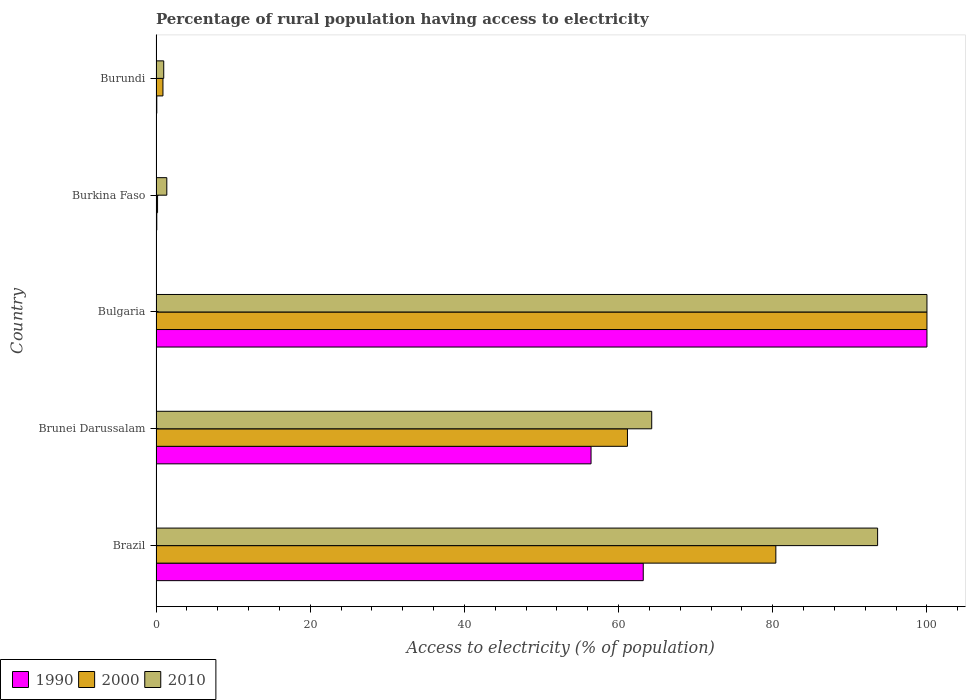How many different coloured bars are there?
Offer a very short reply. 3. How many groups of bars are there?
Give a very brief answer. 5. Are the number of bars per tick equal to the number of legend labels?
Ensure brevity in your answer.  Yes. Are the number of bars on each tick of the Y-axis equal?
Provide a succinct answer. Yes. How many bars are there on the 5th tick from the bottom?
Ensure brevity in your answer.  3. What is the label of the 2nd group of bars from the top?
Keep it short and to the point. Burkina Faso. In how many cases, is the number of bars for a given country not equal to the number of legend labels?
Ensure brevity in your answer.  0. What is the percentage of rural population having access to electricity in 2000 in Brazil?
Your response must be concise. 80.4. In which country was the percentage of rural population having access to electricity in 2000 maximum?
Your answer should be compact. Bulgaria. In which country was the percentage of rural population having access to electricity in 2010 minimum?
Provide a succinct answer. Burundi. What is the total percentage of rural population having access to electricity in 2010 in the graph?
Provide a succinct answer. 260.3. What is the difference between the percentage of rural population having access to electricity in 2000 in Brunei Darussalam and that in Burkina Faso?
Your answer should be very brief. 60.95. What is the difference between the percentage of rural population having access to electricity in 1990 in Brunei Darussalam and the percentage of rural population having access to electricity in 2000 in Brazil?
Make the answer very short. -23.97. What is the average percentage of rural population having access to electricity in 2000 per country?
Keep it short and to the point. 48.53. What is the difference between the percentage of rural population having access to electricity in 1990 and percentage of rural population having access to electricity in 2010 in Burundi?
Make the answer very short. -0.9. What is the ratio of the percentage of rural population having access to electricity in 2010 in Brunei Darussalam to that in Bulgaria?
Provide a short and direct response. 0.64. Is the percentage of rural population having access to electricity in 2010 in Brazil less than that in Burundi?
Make the answer very short. No. Is the difference between the percentage of rural population having access to electricity in 1990 in Brazil and Burkina Faso greater than the difference between the percentage of rural population having access to electricity in 2010 in Brazil and Burkina Faso?
Offer a terse response. No. What is the difference between the highest and the second highest percentage of rural population having access to electricity in 2010?
Your answer should be very brief. 6.4. What is the difference between the highest and the lowest percentage of rural population having access to electricity in 2010?
Your answer should be very brief. 99. In how many countries, is the percentage of rural population having access to electricity in 2010 greater than the average percentage of rural population having access to electricity in 2010 taken over all countries?
Your response must be concise. 3. What does the 2nd bar from the top in Brunei Darussalam represents?
Your answer should be very brief. 2000. How many countries are there in the graph?
Offer a very short reply. 5. Are the values on the major ticks of X-axis written in scientific E-notation?
Make the answer very short. No. What is the title of the graph?
Provide a succinct answer. Percentage of rural population having access to electricity. Does "2004" appear as one of the legend labels in the graph?
Your answer should be very brief. No. What is the label or title of the X-axis?
Your response must be concise. Access to electricity (% of population). What is the Access to electricity (% of population) in 1990 in Brazil?
Keep it short and to the point. 63.2. What is the Access to electricity (% of population) of 2000 in Brazil?
Keep it short and to the point. 80.4. What is the Access to electricity (% of population) of 2010 in Brazil?
Give a very brief answer. 93.6. What is the Access to electricity (% of population) in 1990 in Brunei Darussalam?
Your response must be concise. 56.43. What is the Access to electricity (% of population) in 2000 in Brunei Darussalam?
Offer a very short reply. 61.15. What is the Access to electricity (% of population) of 2010 in Brunei Darussalam?
Ensure brevity in your answer.  64.3. What is the Access to electricity (% of population) of 1990 in Bulgaria?
Your answer should be compact. 100. What is the Access to electricity (% of population) in 2000 in Bulgaria?
Your answer should be very brief. 100. What is the Access to electricity (% of population) in 2010 in Bulgaria?
Offer a terse response. 100. What is the Access to electricity (% of population) of 2010 in Burkina Faso?
Provide a short and direct response. 1.4. What is the Access to electricity (% of population) in 1990 in Burundi?
Provide a short and direct response. 0.1. Across all countries, what is the minimum Access to electricity (% of population) in 1990?
Provide a short and direct response. 0.1. Across all countries, what is the minimum Access to electricity (% of population) in 2000?
Provide a short and direct response. 0.2. Across all countries, what is the minimum Access to electricity (% of population) in 2010?
Provide a succinct answer. 1. What is the total Access to electricity (% of population) of 1990 in the graph?
Your answer should be very brief. 219.83. What is the total Access to electricity (% of population) in 2000 in the graph?
Make the answer very short. 242.65. What is the total Access to electricity (% of population) of 2010 in the graph?
Offer a terse response. 260.3. What is the difference between the Access to electricity (% of population) in 1990 in Brazil and that in Brunei Darussalam?
Provide a succinct answer. 6.77. What is the difference between the Access to electricity (% of population) of 2000 in Brazil and that in Brunei Darussalam?
Provide a succinct answer. 19.25. What is the difference between the Access to electricity (% of population) in 2010 in Brazil and that in Brunei Darussalam?
Offer a terse response. 29.3. What is the difference between the Access to electricity (% of population) in 1990 in Brazil and that in Bulgaria?
Your answer should be compact. -36.8. What is the difference between the Access to electricity (% of population) in 2000 in Brazil and that in Bulgaria?
Make the answer very short. -19.6. What is the difference between the Access to electricity (% of population) of 1990 in Brazil and that in Burkina Faso?
Offer a very short reply. 63.1. What is the difference between the Access to electricity (% of population) in 2000 in Brazil and that in Burkina Faso?
Your answer should be compact. 80.2. What is the difference between the Access to electricity (% of population) of 2010 in Brazil and that in Burkina Faso?
Your answer should be compact. 92.2. What is the difference between the Access to electricity (% of population) of 1990 in Brazil and that in Burundi?
Give a very brief answer. 63.1. What is the difference between the Access to electricity (% of population) of 2000 in Brazil and that in Burundi?
Your response must be concise. 79.5. What is the difference between the Access to electricity (% of population) in 2010 in Brazil and that in Burundi?
Offer a terse response. 92.6. What is the difference between the Access to electricity (% of population) of 1990 in Brunei Darussalam and that in Bulgaria?
Provide a succinct answer. -43.57. What is the difference between the Access to electricity (% of population) in 2000 in Brunei Darussalam and that in Bulgaria?
Ensure brevity in your answer.  -38.85. What is the difference between the Access to electricity (% of population) in 2010 in Brunei Darussalam and that in Bulgaria?
Offer a very short reply. -35.7. What is the difference between the Access to electricity (% of population) in 1990 in Brunei Darussalam and that in Burkina Faso?
Keep it short and to the point. 56.33. What is the difference between the Access to electricity (% of population) in 2000 in Brunei Darussalam and that in Burkina Faso?
Your answer should be compact. 60.95. What is the difference between the Access to electricity (% of population) in 2010 in Brunei Darussalam and that in Burkina Faso?
Your response must be concise. 62.9. What is the difference between the Access to electricity (% of population) of 1990 in Brunei Darussalam and that in Burundi?
Ensure brevity in your answer.  56.33. What is the difference between the Access to electricity (% of population) of 2000 in Brunei Darussalam and that in Burundi?
Provide a succinct answer. 60.25. What is the difference between the Access to electricity (% of population) of 2010 in Brunei Darussalam and that in Burundi?
Ensure brevity in your answer.  63.3. What is the difference between the Access to electricity (% of population) of 1990 in Bulgaria and that in Burkina Faso?
Ensure brevity in your answer.  99.9. What is the difference between the Access to electricity (% of population) in 2000 in Bulgaria and that in Burkina Faso?
Your answer should be very brief. 99.8. What is the difference between the Access to electricity (% of population) in 2010 in Bulgaria and that in Burkina Faso?
Your answer should be compact. 98.6. What is the difference between the Access to electricity (% of population) in 1990 in Bulgaria and that in Burundi?
Make the answer very short. 99.9. What is the difference between the Access to electricity (% of population) of 2000 in Bulgaria and that in Burundi?
Provide a short and direct response. 99.1. What is the difference between the Access to electricity (% of population) in 1990 in Burkina Faso and that in Burundi?
Make the answer very short. 0. What is the difference between the Access to electricity (% of population) in 2010 in Burkina Faso and that in Burundi?
Offer a terse response. 0.4. What is the difference between the Access to electricity (% of population) of 1990 in Brazil and the Access to electricity (% of population) of 2000 in Brunei Darussalam?
Provide a short and direct response. 2.05. What is the difference between the Access to electricity (% of population) in 1990 in Brazil and the Access to electricity (% of population) in 2010 in Brunei Darussalam?
Your answer should be compact. -1.1. What is the difference between the Access to electricity (% of population) of 1990 in Brazil and the Access to electricity (% of population) of 2000 in Bulgaria?
Provide a succinct answer. -36.8. What is the difference between the Access to electricity (% of population) in 1990 in Brazil and the Access to electricity (% of population) in 2010 in Bulgaria?
Give a very brief answer. -36.8. What is the difference between the Access to electricity (% of population) of 2000 in Brazil and the Access to electricity (% of population) of 2010 in Bulgaria?
Ensure brevity in your answer.  -19.6. What is the difference between the Access to electricity (% of population) of 1990 in Brazil and the Access to electricity (% of population) of 2000 in Burkina Faso?
Ensure brevity in your answer.  63. What is the difference between the Access to electricity (% of population) of 1990 in Brazil and the Access to electricity (% of population) of 2010 in Burkina Faso?
Your answer should be compact. 61.8. What is the difference between the Access to electricity (% of population) of 2000 in Brazil and the Access to electricity (% of population) of 2010 in Burkina Faso?
Your answer should be compact. 79. What is the difference between the Access to electricity (% of population) in 1990 in Brazil and the Access to electricity (% of population) in 2000 in Burundi?
Offer a terse response. 62.3. What is the difference between the Access to electricity (% of population) in 1990 in Brazil and the Access to electricity (% of population) in 2010 in Burundi?
Your response must be concise. 62.2. What is the difference between the Access to electricity (% of population) of 2000 in Brazil and the Access to electricity (% of population) of 2010 in Burundi?
Your answer should be compact. 79.4. What is the difference between the Access to electricity (% of population) of 1990 in Brunei Darussalam and the Access to electricity (% of population) of 2000 in Bulgaria?
Ensure brevity in your answer.  -43.57. What is the difference between the Access to electricity (% of population) in 1990 in Brunei Darussalam and the Access to electricity (% of population) in 2010 in Bulgaria?
Offer a very short reply. -43.57. What is the difference between the Access to electricity (% of population) in 2000 in Brunei Darussalam and the Access to electricity (% of population) in 2010 in Bulgaria?
Offer a terse response. -38.85. What is the difference between the Access to electricity (% of population) of 1990 in Brunei Darussalam and the Access to electricity (% of population) of 2000 in Burkina Faso?
Keep it short and to the point. 56.23. What is the difference between the Access to electricity (% of population) of 1990 in Brunei Darussalam and the Access to electricity (% of population) of 2010 in Burkina Faso?
Your response must be concise. 55.03. What is the difference between the Access to electricity (% of population) in 2000 in Brunei Darussalam and the Access to electricity (% of population) in 2010 in Burkina Faso?
Provide a short and direct response. 59.75. What is the difference between the Access to electricity (% of population) in 1990 in Brunei Darussalam and the Access to electricity (% of population) in 2000 in Burundi?
Offer a very short reply. 55.53. What is the difference between the Access to electricity (% of population) in 1990 in Brunei Darussalam and the Access to electricity (% of population) in 2010 in Burundi?
Your answer should be very brief. 55.43. What is the difference between the Access to electricity (% of population) in 2000 in Brunei Darussalam and the Access to electricity (% of population) in 2010 in Burundi?
Your response must be concise. 60.15. What is the difference between the Access to electricity (% of population) in 1990 in Bulgaria and the Access to electricity (% of population) in 2000 in Burkina Faso?
Your answer should be very brief. 99.8. What is the difference between the Access to electricity (% of population) of 1990 in Bulgaria and the Access to electricity (% of population) of 2010 in Burkina Faso?
Offer a very short reply. 98.6. What is the difference between the Access to electricity (% of population) in 2000 in Bulgaria and the Access to electricity (% of population) in 2010 in Burkina Faso?
Your answer should be very brief. 98.6. What is the difference between the Access to electricity (% of population) of 1990 in Bulgaria and the Access to electricity (% of population) of 2000 in Burundi?
Make the answer very short. 99.1. What is the difference between the Access to electricity (% of population) in 1990 in Bulgaria and the Access to electricity (% of population) in 2010 in Burundi?
Your response must be concise. 99. What is the difference between the Access to electricity (% of population) in 1990 in Burkina Faso and the Access to electricity (% of population) in 2000 in Burundi?
Offer a terse response. -0.8. What is the difference between the Access to electricity (% of population) of 1990 in Burkina Faso and the Access to electricity (% of population) of 2010 in Burundi?
Provide a short and direct response. -0.9. What is the average Access to electricity (% of population) in 1990 per country?
Offer a very short reply. 43.97. What is the average Access to electricity (% of population) of 2000 per country?
Your response must be concise. 48.53. What is the average Access to electricity (% of population) in 2010 per country?
Make the answer very short. 52.06. What is the difference between the Access to electricity (% of population) in 1990 and Access to electricity (% of population) in 2000 in Brazil?
Your answer should be compact. -17.2. What is the difference between the Access to electricity (% of population) of 1990 and Access to electricity (% of population) of 2010 in Brazil?
Your response must be concise. -30.4. What is the difference between the Access to electricity (% of population) of 1990 and Access to electricity (% of population) of 2000 in Brunei Darussalam?
Provide a short and direct response. -4.72. What is the difference between the Access to electricity (% of population) of 1990 and Access to electricity (% of population) of 2010 in Brunei Darussalam?
Ensure brevity in your answer.  -7.87. What is the difference between the Access to electricity (% of population) in 2000 and Access to electricity (% of population) in 2010 in Brunei Darussalam?
Ensure brevity in your answer.  -3.15. What is the difference between the Access to electricity (% of population) in 1990 and Access to electricity (% of population) in 2000 in Bulgaria?
Your answer should be compact. 0. What is the difference between the Access to electricity (% of population) of 1990 and Access to electricity (% of population) of 2010 in Bulgaria?
Provide a short and direct response. 0. What is the difference between the Access to electricity (% of population) of 2000 and Access to electricity (% of population) of 2010 in Bulgaria?
Ensure brevity in your answer.  0. What is the difference between the Access to electricity (% of population) in 1990 and Access to electricity (% of population) in 2000 in Burkina Faso?
Give a very brief answer. -0.1. What is the difference between the Access to electricity (% of population) in 1990 and Access to electricity (% of population) in 2010 in Burkina Faso?
Provide a succinct answer. -1.3. What is the ratio of the Access to electricity (% of population) of 1990 in Brazil to that in Brunei Darussalam?
Offer a very short reply. 1.12. What is the ratio of the Access to electricity (% of population) in 2000 in Brazil to that in Brunei Darussalam?
Your response must be concise. 1.31. What is the ratio of the Access to electricity (% of population) of 2010 in Brazil to that in Brunei Darussalam?
Make the answer very short. 1.46. What is the ratio of the Access to electricity (% of population) of 1990 in Brazil to that in Bulgaria?
Provide a succinct answer. 0.63. What is the ratio of the Access to electricity (% of population) of 2000 in Brazil to that in Bulgaria?
Your answer should be very brief. 0.8. What is the ratio of the Access to electricity (% of population) in 2010 in Brazil to that in Bulgaria?
Offer a very short reply. 0.94. What is the ratio of the Access to electricity (% of population) of 1990 in Brazil to that in Burkina Faso?
Make the answer very short. 632. What is the ratio of the Access to electricity (% of population) in 2000 in Brazil to that in Burkina Faso?
Provide a succinct answer. 402. What is the ratio of the Access to electricity (% of population) of 2010 in Brazil to that in Burkina Faso?
Your response must be concise. 66.86. What is the ratio of the Access to electricity (% of population) of 1990 in Brazil to that in Burundi?
Your response must be concise. 632. What is the ratio of the Access to electricity (% of population) of 2000 in Brazil to that in Burundi?
Give a very brief answer. 89.33. What is the ratio of the Access to electricity (% of population) in 2010 in Brazil to that in Burundi?
Provide a succinct answer. 93.6. What is the ratio of the Access to electricity (% of population) of 1990 in Brunei Darussalam to that in Bulgaria?
Provide a short and direct response. 0.56. What is the ratio of the Access to electricity (% of population) of 2000 in Brunei Darussalam to that in Bulgaria?
Ensure brevity in your answer.  0.61. What is the ratio of the Access to electricity (% of population) in 2010 in Brunei Darussalam to that in Bulgaria?
Make the answer very short. 0.64. What is the ratio of the Access to electricity (% of population) in 1990 in Brunei Darussalam to that in Burkina Faso?
Provide a succinct answer. 564.28. What is the ratio of the Access to electricity (% of population) of 2000 in Brunei Darussalam to that in Burkina Faso?
Your answer should be very brief. 305.75. What is the ratio of the Access to electricity (% of population) in 2010 in Brunei Darussalam to that in Burkina Faso?
Ensure brevity in your answer.  45.93. What is the ratio of the Access to electricity (% of population) of 1990 in Brunei Darussalam to that in Burundi?
Your response must be concise. 564.28. What is the ratio of the Access to electricity (% of population) of 2000 in Brunei Darussalam to that in Burundi?
Offer a terse response. 67.95. What is the ratio of the Access to electricity (% of population) in 2010 in Brunei Darussalam to that in Burundi?
Your response must be concise. 64.3. What is the ratio of the Access to electricity (% of population) of 2010 in Bulgaria to that in Burkina Faso?
Ensure brevity in your answer.  71.43. What is the ratio of the Access to electricity (% of population) of 2000 in Bulgaria to that in Burundi?
Give a very brief answer. 111.11. What is the ratio of the Access to electricity (% of population) in 2010 in Bulgaria to that in Burundi?
Your answer should be compact. 100. What is the ratio of the Access to electricity (% of population) of 1990 in Burkina Faso to that in Burundi?
Provide a succinct answer. 1. What is the ratio of the Access to electricity (% of population) of 2000 in Burkina Faso to that in Burundi?
Offer a terse response. 0.22. What is the ratio of the Access to electricity (% of population) in 2010 in Burkina Faso to that in Burundi?
Provide a succinct answer. 1.4. What is the difference between the highest and the second highest Access to electricity (% of population) in 1990?
Make the answer very short. 36.8. What is the difference between the highest and the second highest Access to electricity (% of population) in 2000?
Keep it short and to the point. 19.6. What is the difference between the highest and the lowest Access to electricity (% of population) in 1990?
Offer a terse response. 99.9. What is the difference between the highest and the lowest Access to electricity (% of population) of 2000?
Provide a succinct answer. 99.8. 